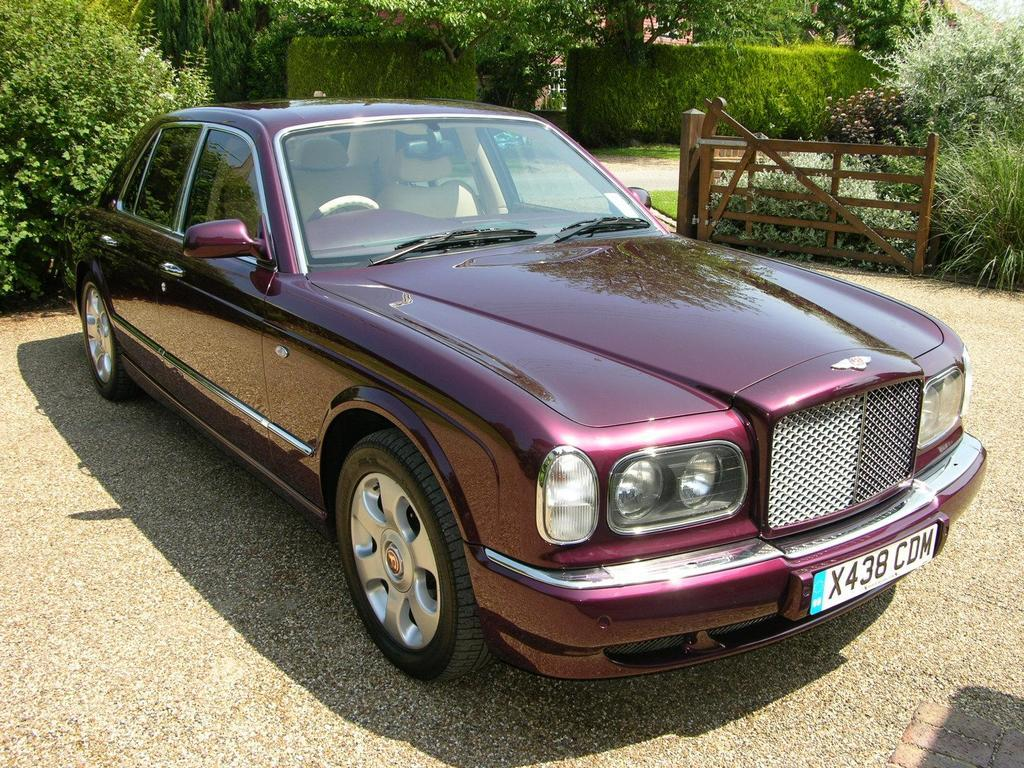What is the main subject of the image? There is a vehicle in the image. What can be seen beneath the vehicle? The ground is visible in the image. What type of vegetation is present in the image? There are plants in the image. What type of barrier is visible in the image? There is wooden fencing in the image. How many boats are visible in the image? There are no boats present in the image. What type of sorting activity is taking place in the image? There is no sorting activity present in the image. 